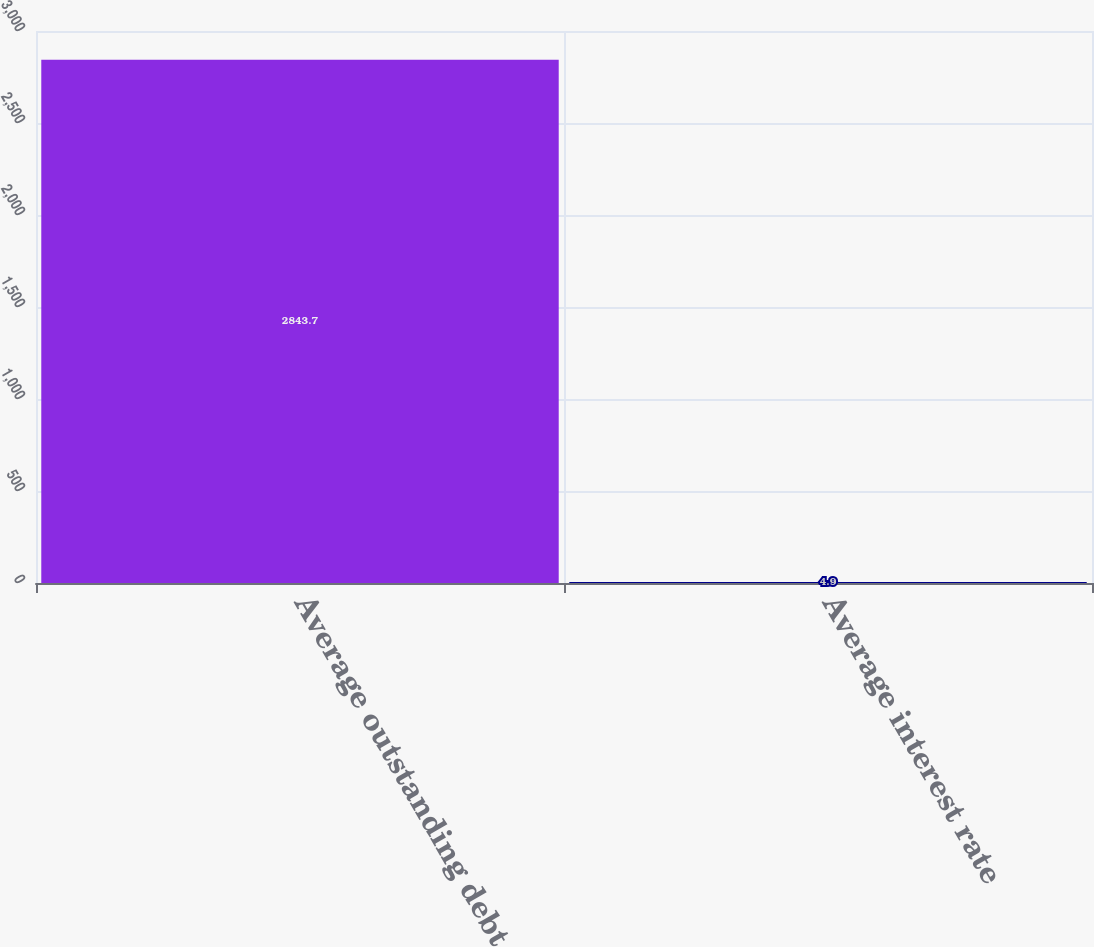Convert chart to OTSL. <chart><loc_0><loc_0><loc_500><loc_500><bar_chart><fcel>Average outstanding debt<fcel>Average interest rate<nl><fcel>2843.7<fcel>4.9<nl></chart> 